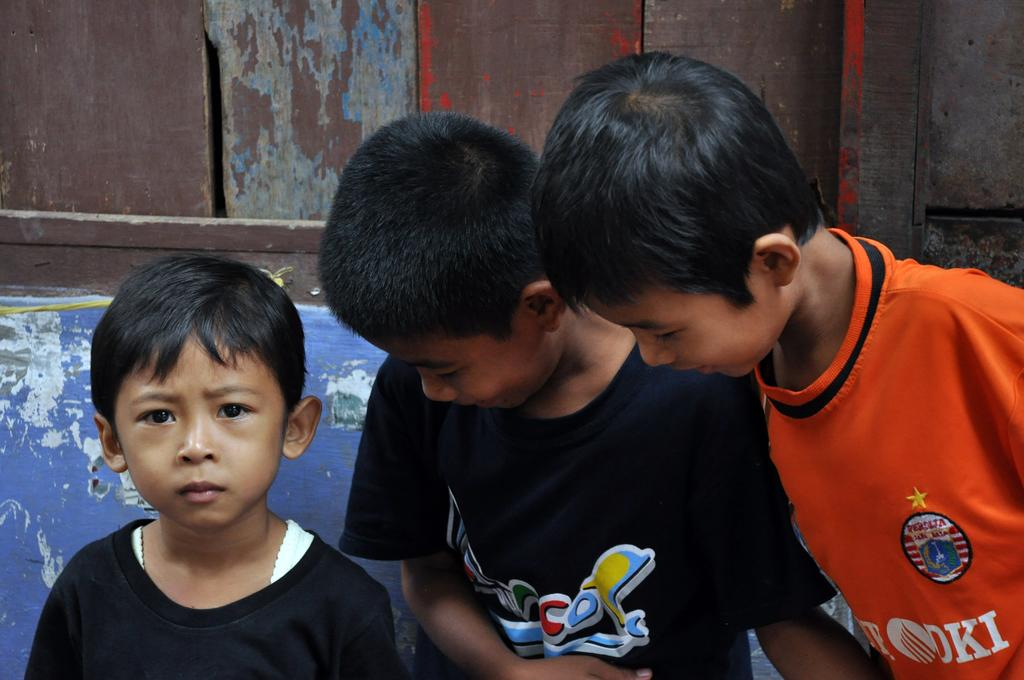How many people are standing in the front of the image? There are three people standing in the front of the image. What are the two people on the left side wearing? The two people on the left side are wearing black t-shirts. What color t-shirt is the boy on the right side wearing? The boy on the right side is wearing an orange t-shirt. What type of beef is being served at the society event in the image? There is no beef or society event present in the image; it features three people standing in front of a background. 